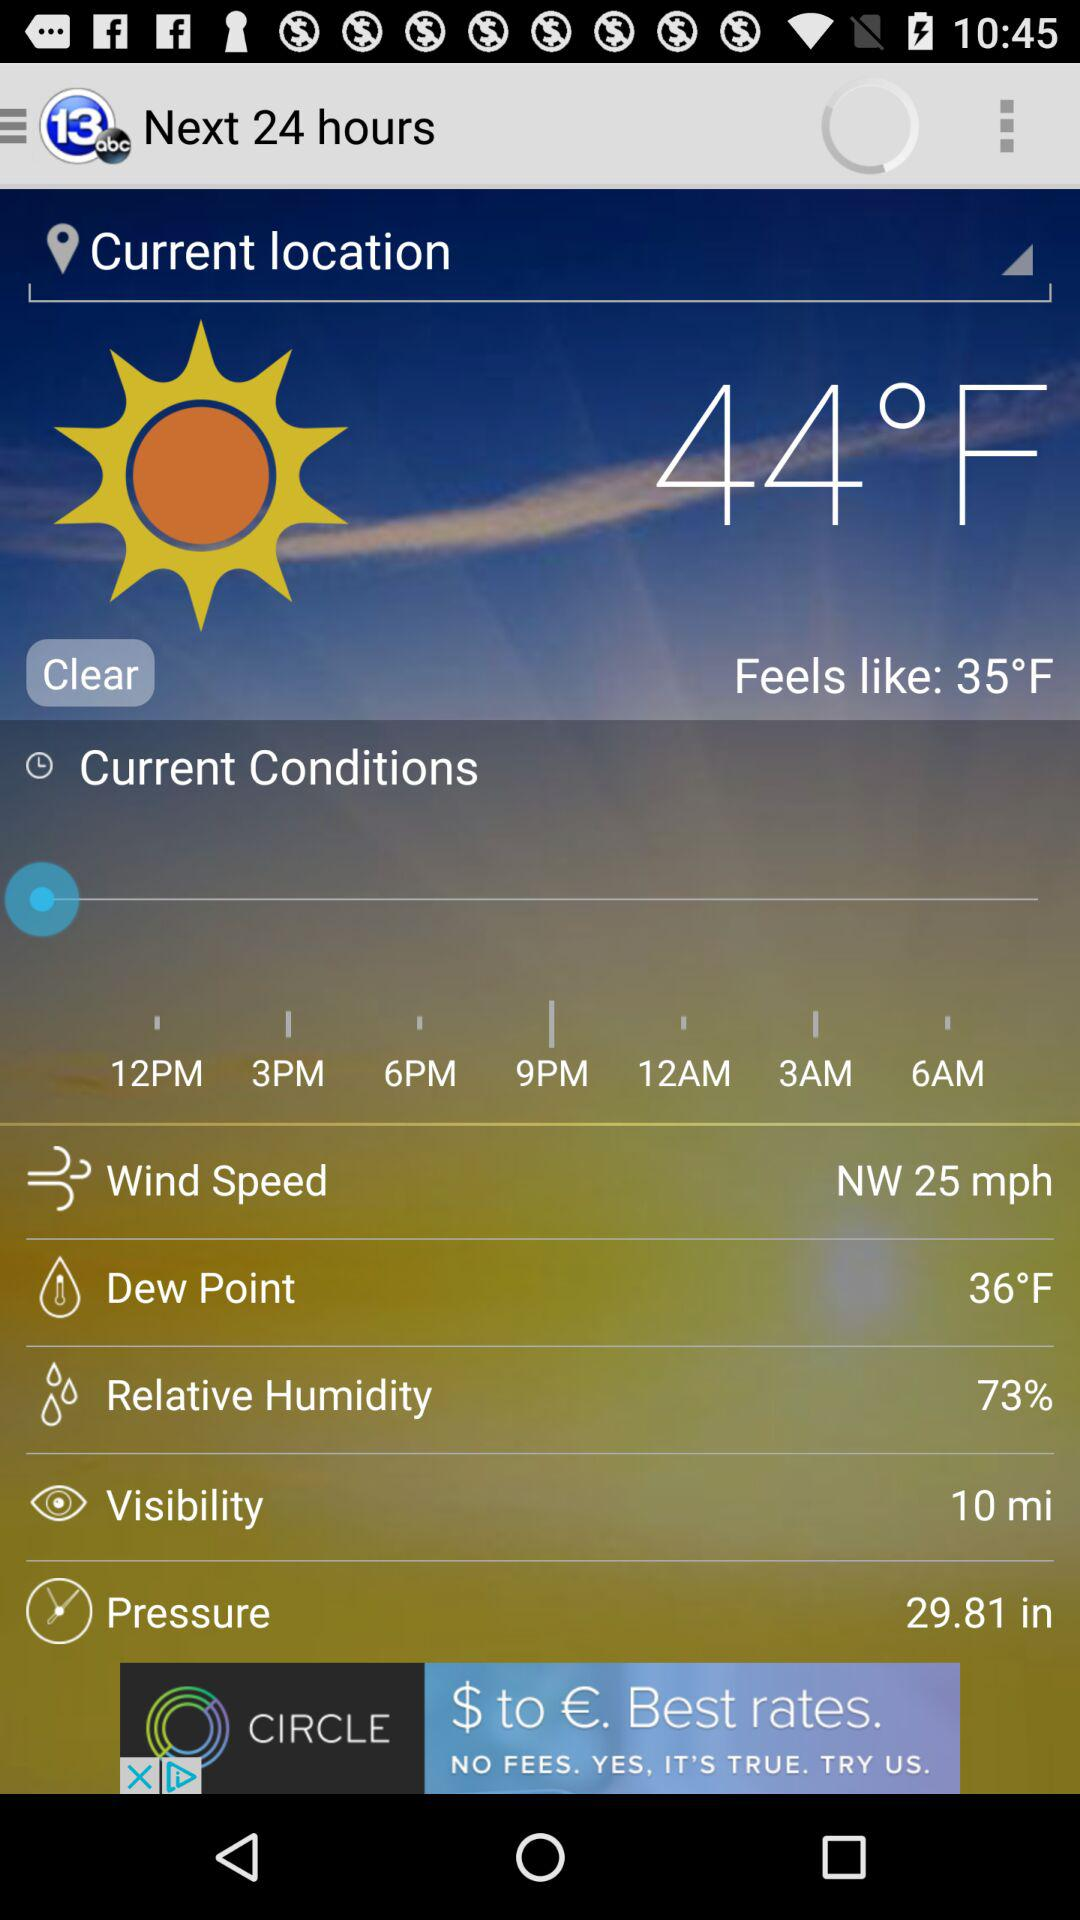What is the relative humidity of the current weather conditions?
Answer the question using a single word or phrase. 73% 